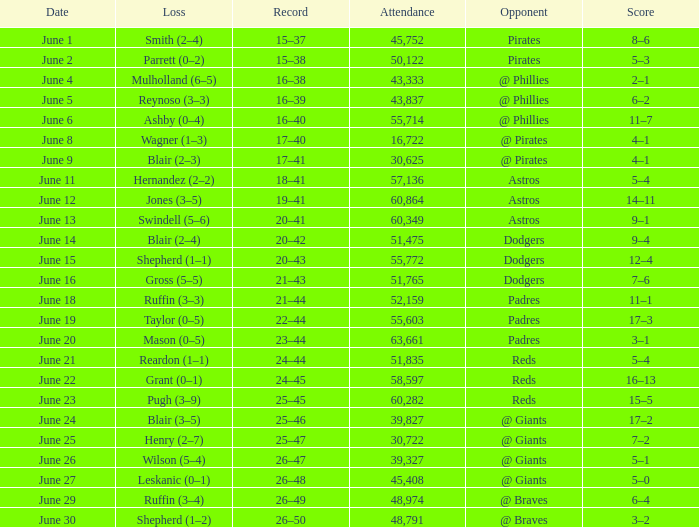What was the score on June 12? 14–11. 